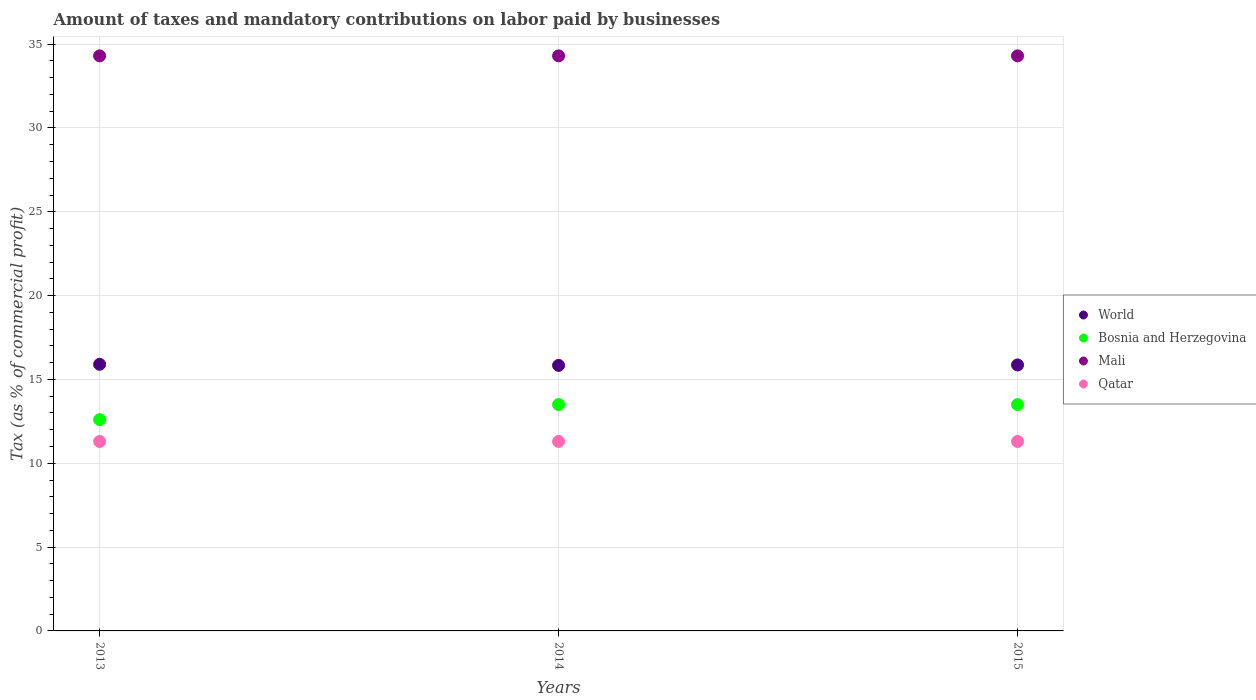Is the number of dotlines equal to the number of legend labels?
Keep it short and to the point. Yes. What is the percentage of taxes paid by businesses in Mali in 2013?
Ensure brevity in your answer.  34.3. Across all years, what is the maximum percentage of taxes paid by businesses in World?
Make the answer very short. 15.9. In which year was the percentage of taxes paid by businesses in World maximum?
Keep it short and to the point. 2013. What is the total percentage of taxes paid by businesses in Bosnia and Herzegovina in the graph?
Provide a succinct answer. 39.6. What is the difference between the percentage of taxes paid by businesses in World in 2014 and that in 2015?
Your answer should be compact. -0.03. What is the difference between the percentage of taxes paid by businesses in Bosnia and Herzegovina in 2015 and the percentage of taxes paid by businesses in Qatar in 2013?
Keep it short and to the point. 2.2. What is the average percentage of taxes paid by businesses in World per year?
Your answer should be very brief. 15.87. In the year 2013, what is the difference between the percentage of taxes paid by businesses in Qatar and percentage of taxes paid by businesses in Bosnia and Herzegovina?
Provide a short and direct response. -1.3. What is the ratio of the percentage of taxes paid by businesses in Mali in 2014 to that in 2015?
Offer a very short reply. 1. Is the difference between the percentage of taxes paid by businesses in Qatar in 2013 and 2014 greater than the difference between the percentage of taxes paid by businesses in Bosnia and Herzegovina in 2013 and 2014?
Provide a succinct answer. Yes. What is the difference between the highest and the second highest percentage of taxes paid by businesses in Mali?
Your response must be concise. 0. What is the difference between the highest and the lowest percentage of taxes paid by businesses in Qatar?
Offer a terse response. 0. In how many years, is the percentage of taxes paid by businesses in World greater than the average percentage of taxes paid by businesses in World taken over all years?
Provide a succinct answer. 1. Is the sum of the percentage of taxes paid by businesses in World in 2013 and 2014 greater than the maximum percentage of taxes paid by businesses in Qatar across all years?
Offer a very short reply. Yes. Is it the case that in every year, the sum of the percentage of taxes paid by businesses in Qatar and percentage of taxes paid by businesses in World  is greater than the percentage of taxes paid by businesses in Bosnia and Herzegovina?
Offer a terse response. Yes. Does the percentage of taxes paid by businesses in World monotonically increase over the years?
Your answer should be compact. No. What is the title of the graph?
Offer a very short reply. Amount of taxes and mandatory contributions on labor paid by businesses. Does "Uganda" appear as one of the legend labels in the graph?
Your response must be concise. No. What is the label or title of the Y-axis?
Make the answer very short. Tax (as % of commercial profit). What is the Tax (as % of commercial profit) in World in 2013?
Keep it short and to the point. 15.9. What is the Tax (as % of commercial profit) of Bosnia and Herzegovina in 2013?
Provide a short and direct response. 12.6. What is the Tax (as % of commercial profit) of Mali in 2013?
Keep it short and to the point. 34.3. What is the Tax (as % of commercial profit) in Qatar in 2013?
Keep it short and to the point. 11.3. What is the Tax (as % of commercial profit) in World in 2014?
Offer a terse response. 15.84. What is the Tax (as % of commercial profit) of Bosnia and Herzegovina in 2014?
Offer a very short reply. 13.5. What is the Tax (as % of commercial profit) in Mali in 2014?
Provide a succinct answer. 34.3. What is the Tax (as % of commercial profit) in World in 2015?
Make the answer very short. 15.86. What is the Tax (as % of commercial profit) in Bosnia and Herzegovina in 2015?
Provide a succinct answer. 13.5. What is the Tax (as % of commercial profit) of Mali in 2015?
Your response must be concise. 34.3. Across all years, what is the maximum Tax (as % of commercial profit) in World?
Offer a very short reply. 15.9. Across all years, what is the maximum Tax (as % of commercial profit) of Bosnia and Herzegovina?
Offer a very short reply. 13.5. Across all years, what is the maximum Tax (as % of commercial profit) of Mali?
Keep it short and to the point. 34.3. Across all years, what is the maximum Tax (as % of commercial profit) in Qatar?
Keep it short and to the point. 11.3. Across all years, what is the minimum Tax (as % of commercial profit) of World?
Your response must be concise. 15.84. Across all years, what is the minimum Tax (as % of commercial profit) in Mali?
Provide a succinct answer. 34.3. What is the total Tax (as % of commercial profit) of World in the graph?
Ensure brevity in your answer.  47.6. What is the total Tax (as % of commercial profit) in Bosnia and Herzegovina in the graph?
Your answer should be very brief. 39.6. What is the total Tax (as % of commercial profit) of Mali in the graph?
Offer a very short reply. 102.9. What is the total Tax (as % of commercial profit) of Qatar in the graph?
Your answer should be compact. 33.9. What is the difference between the Tax (as % of commercial profit) in World in 2013 and that in 2014?
Offer a very short reply. 0.06. What is the difference between the Tax (as % of commercial profit) in Mali in 2013 and that in 2014?
Your response must be concise. 0. What is the difference between the Tax (as % of commercial profit) of Qatar in 2013 and that in 2014?
Your response must be concise. 0. What is the difference between the Tax (as % of commercial profit) in World in 2013 and that in 2015?
Your response must be concise. 0.04. What is the difference between the Tax (as % of commercial profit) in Mali in 2013 and that in 2015?
Keep it short and to the point. 0. What is the difference between the Tax (as % of commercial profit) in World in 2014 and that in 2015?
Give a very brief answer. -0.03. What is the difference between the Tax (as % of commercial profit) of Mali in 2014 and that in 2015?
Give a very brief answer. 0. What is the difference between the Tax (as % of commercial profit) of World in 2013 and the Tax (as % of commercial profit) of Bosnia and Herzegovina in 2014?
Your response must be concise. 2.4. What is the difference between the Tax (as % of commercial profit) in World in 2013 and the Tax (as % of commercial profit) in Mali in 2014?
Offer a very short reply. -18.4. What is the difference between the Tax (as % of commercial profit) of World in 2013 and the Tax (as % of commercial profit) of Qatar in 2014?
Offer a very short reply. 4.6. What is the difference between the Tax (as % of commercial profit) of Bosnia and Herzegovina in 2013 and the Tax (as % of commercial profit) of Mali in 2014?
Provide a short and direct response. -21.7. What is the difference between the Tax (as % of commercial profit) of World in 2013 and the Tax (as % of commercial profit) of Bosnia and Herzegovina in 2015?
Your answer should be compact. 2.4. What is the difference between the Tax (as % of commercial profit) in World in 2013 and the Tax (as % of commercial profit) in Mali in 2015?
Offer a terse response. -18.4. What is the difference between the Tax (as % of commercial profit) of World in 2013 and the Tax (as % of commercial profit) of Qatar in 2015?
Provide a short and direct response. 4.6. What is the difference between the Tax (as % of commercial profit) of Bosnia and Herzegovina in 2013 and the Tax (as % of commercial profit) of Mali in 2015?
Offer a very short reply. -21.7. What is the difference between the Tax (as % of commercial profit) in Bosnia and Herzegovina in 2013 and the Tax (as % of commercial profit) in Qatar in 2015?
Provide a short and direct response. 1.3. What is the difference between the Tax (as % of commercial profit) in World in 2014 and the Tax (as % of commercial profit) in Bosnia and Herzegovina in 2015?
Keep it short and to the point. 2.34. What is the difference between the Tax (as % of commercial profit) of World in 2014 and the Tax (as % of commercial profit) of Mali in 2015?
Keep it short and to the point. -18.46. What is the difference between the Tax (as % of commercial profit) of World in 2014 and the Tax (as % of commercial profit) of Qatar in 2015?
Make the answer very short. 4.54. What is the difference between the Tax (as % of commercial profit) of Bosnia and Herzegovina in 2014 and the Tax (as % of commercial profit) of Mali in 2015?
Your response must be concise. -20.8. What is the difference between the Tax (as % of commercial profit) of Bosnia and Herzegovina in 2014 and the Tax (as % of commercial profit) of Qatar in 2015?
Keep it short and to the point. 2.2. What is the difference between the Tax (as % of commercial profit) of Mali in 2014 and the Tax (as % of commercial profit) of Qatar in 2015?
Offer a terse response. 23. What is the average Tax (as % of commercial profit) in World per year?
Keep it short and to the point. 15.87. What is the average Tax (as % of commercial profit) in Bosnia and Herzegovina per year?
Your answer should be very brief. 13.2. What is the average Tax (as % of commercial profit) in Mali per year?
Keep it short and to the point. 34.3. What is the average Tax (as % of commercial profit) of Qatar per year?
Ensure brevity in your answer.  11.3. In the year 2013, what is the difference between the Tax (as % of commercial profit) in World and Tax (as % of commercial profit) in Bosnia and Herzegovina?
Provide a succinct answer. 3.3. In the year 2013, what is the difference between the Tax (as % of commercial profit) in World and Tax (as % of commercial profit) in Mali?
Keep it short and to the point. -18.4. In the year 2013, what is the difference between the Tax (as % of commercial profit) in World and Tax (as % of commercial profit) in Qatar?
Provide a short and direct response. 4.6. In the year 2013, what is the difference between the Tax (as % of commercial profit) of Bosnia and Herzegovina and Tax (as % of commercial profit) of Mali?
Make the answer very short. -21.7. In the year 2013, what is the difference between the Tax (as % of commercial profit) of Bosnia and Herzegovina and Tax (as % of commercial profit) of Qatar?
Offer a very short reply. 1.3. In the year 2013, what is the difference between the Tax (as % of commercial profit) of Mali and Tax (as % of commercial profit) of Qatar?
Your response must be concise. 23. In the year 2014, what is the difference between the Tax (as % of commercial profit) in World and Tax (as % of commercial profit) in Bosnia and Herzegovina?
Keep it short and to the point. 2.34. In the year 2014, what is the difference between the Tax (as % of commercial profit) in World and Tax (as % of commercial profit) in Mali?
Make the answer very short. -18.46. In the year 2014, what is the difference between the Tax (as % of commercial profit) of World and Tax (as % of commercial profit) of Qatar?
Give a very brief answer. 4.54. In the year 2014, what is the difference between the Tax (as % of commercial profit) in Bosnia and Herzegovina and Tax (as % of commercial profit) in Mali?
Ensure brevity in your answer.  -20.8. In the year 2014, what is the difference between the Tax (as % of commercial profit) in Bosnia and Herzegovina and Tax (as % of commercial profit) in Qatar?
Your answer should be very brief. 2.2. In the year 2014, what is the difference between the Tax (as % of commercial profit) of Mali and Tax (as % of commercial profit) of Qatar?
Your response must be concise. 23. In the year 2015, what is the difference between the Tax (as % of commercial profit) in World and Tax (as % of commercial profit) in Bosnia and Herzegovina?
Keep it short and to the point. 2.36. In the year 2015, what is the difference between the Tax (as % of commercial profit) of World and Tax (as % of commercial profit) of Mali?
Your answer should be compact. -18.44. In the year 2015, what is the difference between the Tax (as % of commercial profit) of World and Tax (as % of commercial profit) of Qatar?
Provide a short and direct response. 4.56. In the year 2015, what is the difference between the Tax (as % of commercial profit) of Bosnia and Herzegovina and Tax (as % of commercial profit) of Mali?
Offer a very short reply. -20.8. In the year 2015, what is the difference between the Tax (as % of commercial profit) in Bosnia and Herzegovina and Tax (as % of commercial profit) in Qatar?
Offer a very short reply. 2.2. In the year 2015, what is the difference between the Tax (as % of commercial profit) in Mali and Tax (as % of commercial profit) in Qatar?
Provide a succinct answer. 23. What is the ratio of the Tax (as % of commercial profit) of Bosnia and Herzegovina in 2013 to that in 2014?
Give a very brief answer. 0.93. What is the ratio of the Tax (as % of commercial profit) of Qatar in 2013 to that in 2014?
Your response must be concise. 1. What is the ratio of the Tax (as % of commercial profit) in World in 2013 to that in 2015?
Provide a short and direct response. 1. What is the ratio of the Tax (as % of commercial profit) in Qatar in 2013 to that in 2015?
Make the answer very short. 1. What is the ratio of the Tax (as % of commercial profit) of World in 2014 to that in 2015?
Give a very brief answer. 1. What is the ratio of the Tax (as % of commercial profit) in Mali in 2014 to that in 2015?
Your response must be concise. 1. What is the ratio of the Tax (as % of commercial profit) in Qatar in 2014 to that in 2015?
Ensure brevity in your answer.  1. What is the difference between the highest and the second highest Tax (as % of commercial profit) of World?
Provide a succinct answer. 0.04. What is the difference between the highest and the second highest Tax (as % of commercial profit) in Mali?
Ensure brevity in your answer.  0. What is the difference between the highest and the lowest Tax (as % of commercial profit) of World?
Keep it short and to the point. 0.06. What is the difference between the highest and the lowest Tax (as % of commercial profit) of Qatar?
Offer a terse response. 0. 